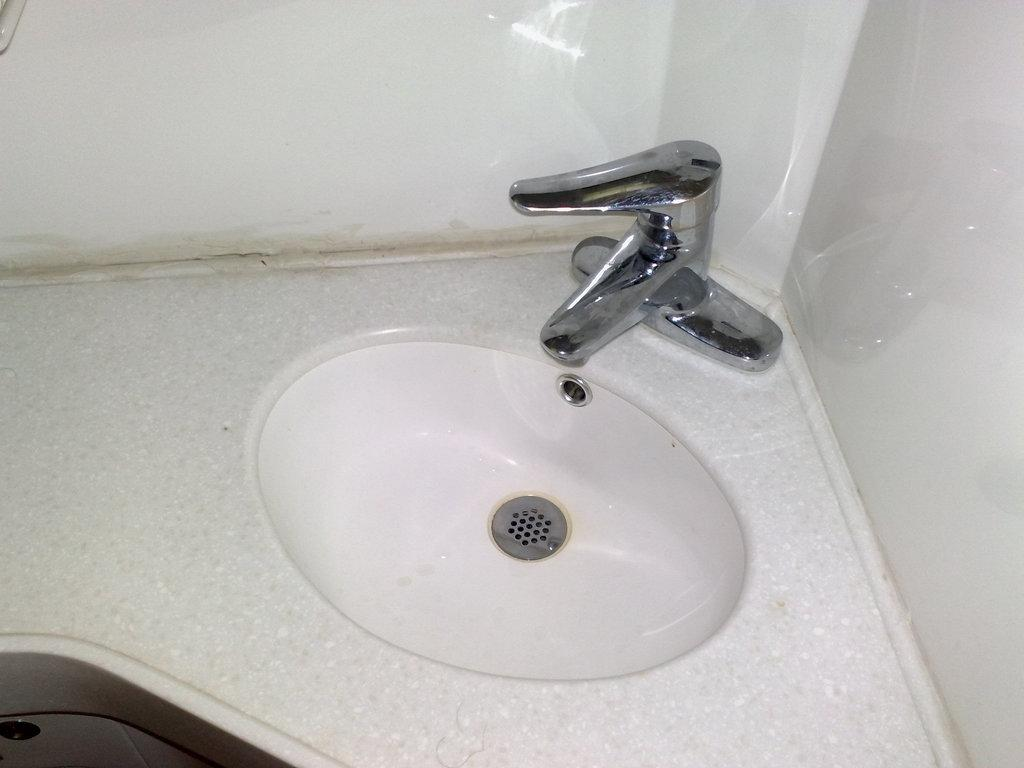What can be seen in the image that is used for washing hands? There is a wash basin in the image. What feature is present in the wash basin? There is a tap in the image. What can be seen surrounding the wash basin and tap? The walls are visible in the image. What type of judge is depicted in the image? There is no judge present in the image; it features a wash basin and a tap. How does the balloon adjust its position in the image? There is no balloon present in the image; it only features a wash basin and a tap. 